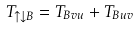Convert formula to latex. <formula><loc_0><loc_0><loc_500><loc_500>T _ { \uparrow \downarrow B } = T _ { B v u } + T _ { B u v }</formula> 